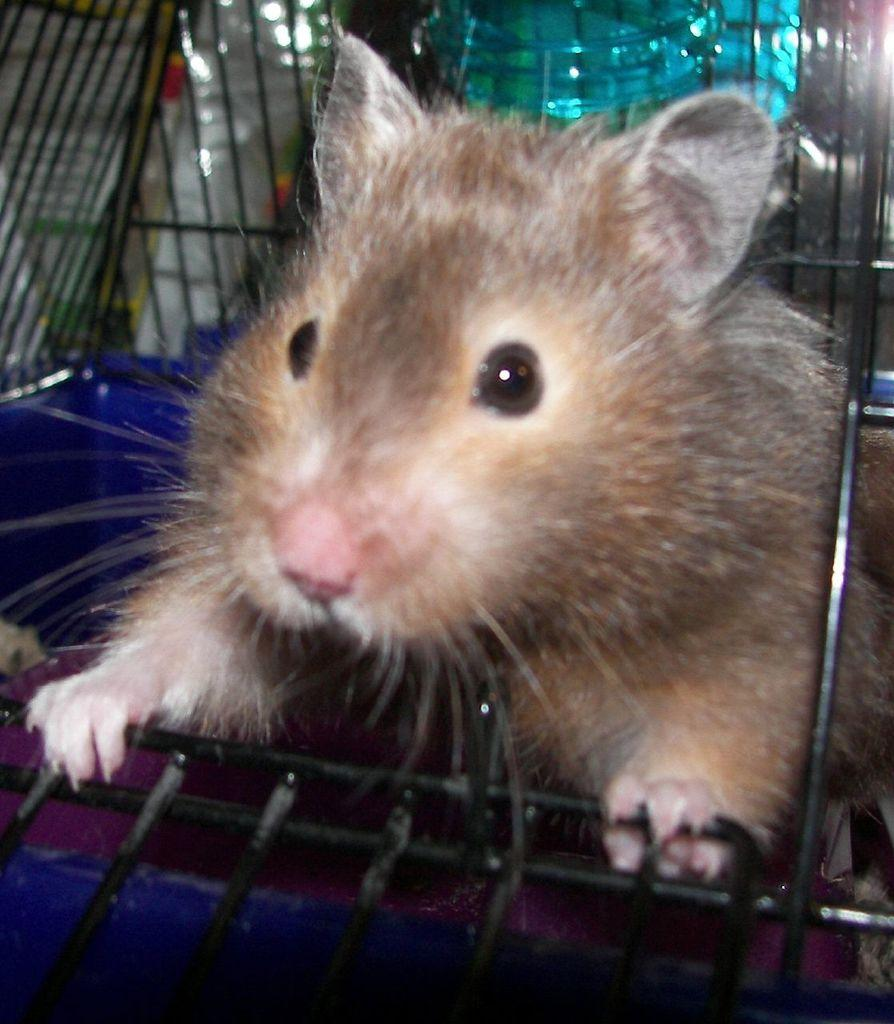What animal is present in the image? There is a rat in the image. Where is the rat located? The rat is in a cage. What type of wound can be seen on the rat in the image? There is no wound visible on the rat in the image, as it is in a cage and not injured. 